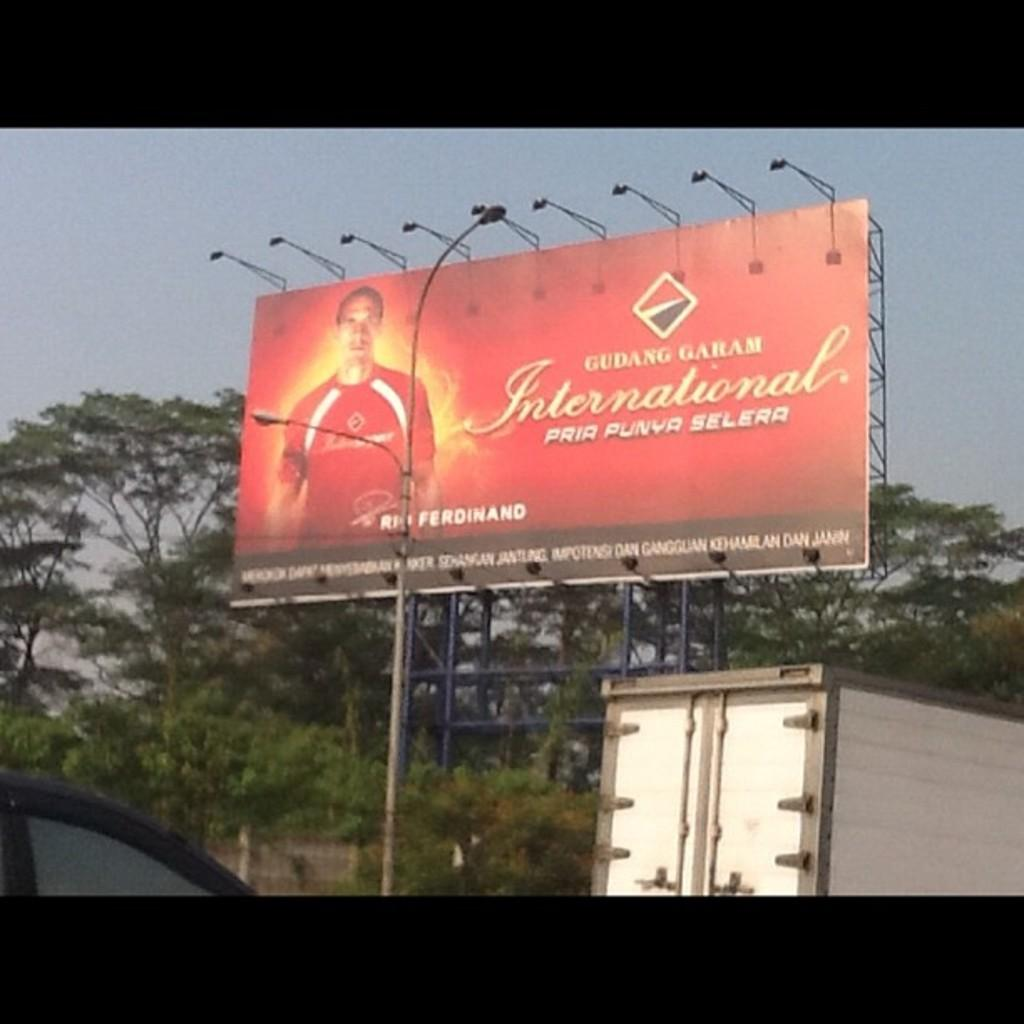Provide a one-sentence caption for the provided image. An outdoor billboard in red with a soccer player named Rio Ferdinand on it. 